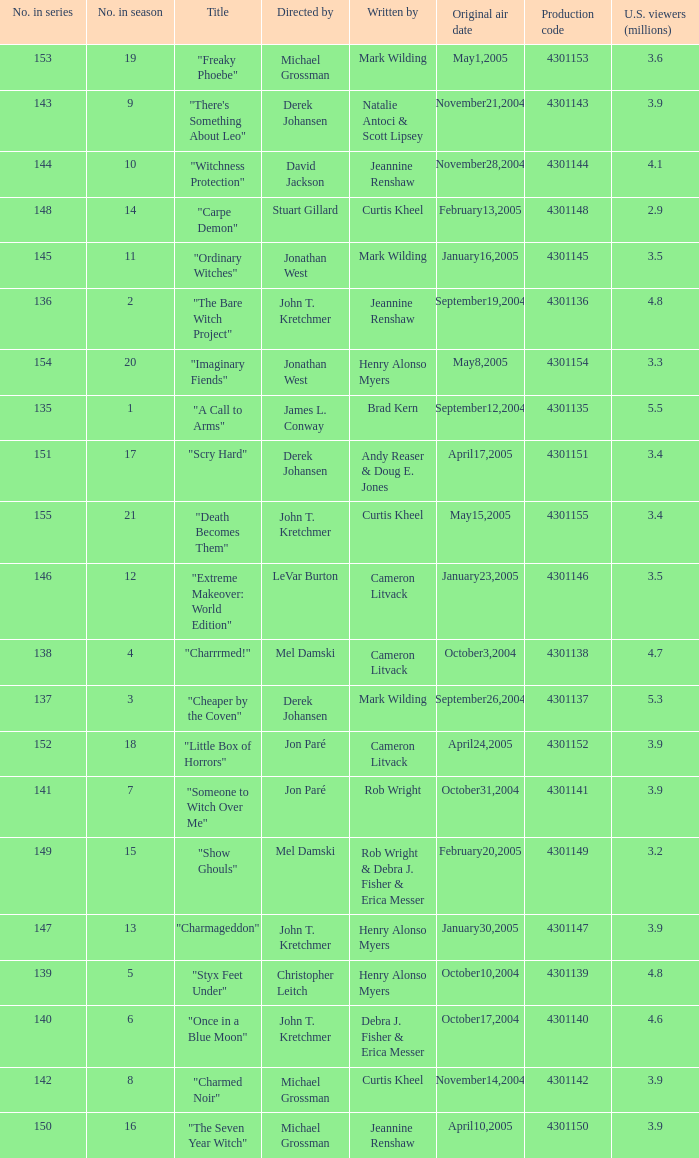In season number 3,  who were the writers? Mark Wilding. 